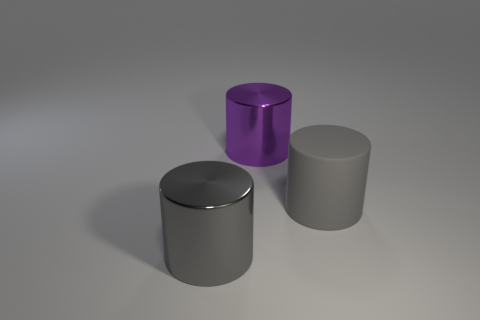Subtract all cyan cylinders. Subtract all blue spheres. How many cylinders are left? 3 Add 1 small blue things. How many objects exist? 4 Add 3 large gray cylinders. How many large gray cylinders are left? 5 Add 3 big brown matte objects. How many big brown matte objects exist? 3 Subtract 0 yellow balls. How many objects are left? 3 Subtract all large matte cylinders. Subtract all gray shiny objects. How many objects are left? 1 